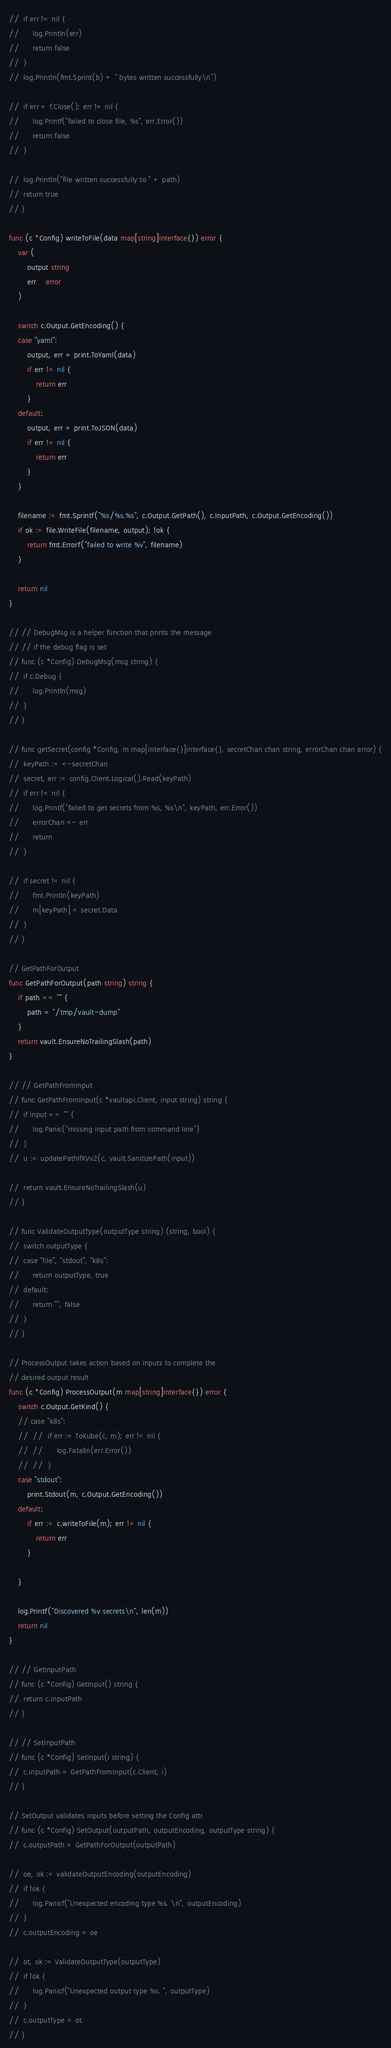<code> <loc_0><loc_0><loc_500><loc_500><_Go_>// 	if err != nil {
// 		log.Println(err)
// 		return false
// 	}
// 	log.Println(fmt.Sprint(b) + " bytes written successfully\n")

// 	if err = f.Close(); err != nil {
// 		log.Printf("failed to close file, %s", err.Error())
// 		return false
// 	}

// 	log.Println("file written successfully to " + path)
// 	return true
// }

func (c *Config) writeToFile(data map[string]interface{}) error {
	var (
		output string
		err    error
	)

	switch c.Output.GetEncoding() {
	case "yaml":
		output, err = print.ToYaml(data)
		if err != nil {
			return err
		}
	default:
		output, err = print.ToJSON(data)
		if err != nil {
			return err
		}
	}

	filename := fmt.Sprintf("%s/%s.%s", c.Output.GetPath(), c.InputPath, c.Output.GetEncoding())
	if ok := file.WriteFile(filename, output); !ok {
		return fmt.Errorf("failed to write %v", filename)
	}

	return nil
}

// // DebugMsg is a helper function that prints the message
// // if the debug flag is set
// func (c *Config) DebugMsg(msg string) {
// 	if c.Debug {
// 		log.Println(msg)
// 	}
// }

// func getSecret(config *Config, m map[interface{}]interface{}, secretChan chan string, errorChan chan error) {
// 	keyPath := <-secretChan
// 	secret, err := config.Client.Logical().Read(keyPath)
// 	if err != nil {
// 		log.Printf("failed to get secrets from %s, %s\n", keyPath, err.Error())
// 		errorChan <- err
// 		return
// 	}

// 	if secret != nil {
// 		fmt.Println(keyPath)
// 		m[keyPath] = secret.Data
// 	}
// }

// GetPathForOutput
func GetPathForOutput(path string) string {
	if path == "" {
		path = "/tmp/vault-dump"
	}
	return vault.EnsureNoTrailingSlash(path)
}

// // GetPathFromInput
// func GetPathFromInput(c *vaultapi.Client, input string) string {
// 	if input == "" {
// 		log.Panic("missing input path from command line")
// 	}
// 	u := updatePathIfKVv2(c, vault.SanitizePath(input))

// 	return vault.EnsureNoTrailingSlash(u)
// }

// func ValidateOutputType(outputType string) (string, bool) {
// 	switch outputType {
// 	case "file", "stdout", "k8s":
// 		return outputType, true
// 	default:
// 		return "", false
// 	}
// }

// ProcessOutput takes action based on inputs to complete the
// desired output result
func (c *Config) ProcessOutput(m map[string]interface{}) error {
	switch c.Output.GetKind() {
	// case "k8s":
	// 	// 	if err := ToKube(c, m); err != nil {
	// 	// 		log.Fatalln(err.Error())
	// 	// 	}
	case "stdout":
		print.Stdout(m, c.Output.GetEncoding())
	default:
		if err := c.writeToFile(m); err != nil {
			return err
		}

	}

	log.Printf("Discovered %v secrets\n", len(m))
	return nil
}

// // GetInputPath
// func (c *Config) GetInput() string {
// 	return c.inputPath
// }

// // SetInputPath
// func (c *Config) SetInput(i string) {
// 	c.inputPath = GetPathFromInput(c.Client, i)
// }

// SetOutput validates inputs before setting the Config attr
// func (c *Config) SetOutput(outputPath, outputEncoding, outputType string) {
// 	c.outputPath = GetPathForOutput(outputPath)

// 	oe, ok := validateOutputEncoding(outputEncoding)
// 	if !ok {
// 		log.Panicf("Unexpected encoding type %s. \n", outputEncoding)
// 	}
// 	c.outputEncoding = oe

// 	ot, ok := ValidateOutputType(outputType)
// 	if !ok {
// 		log.Panicf("Unexpected output type %s. ", outputType)
// 	}
// 	c.outputType = ot
// }
</code> 